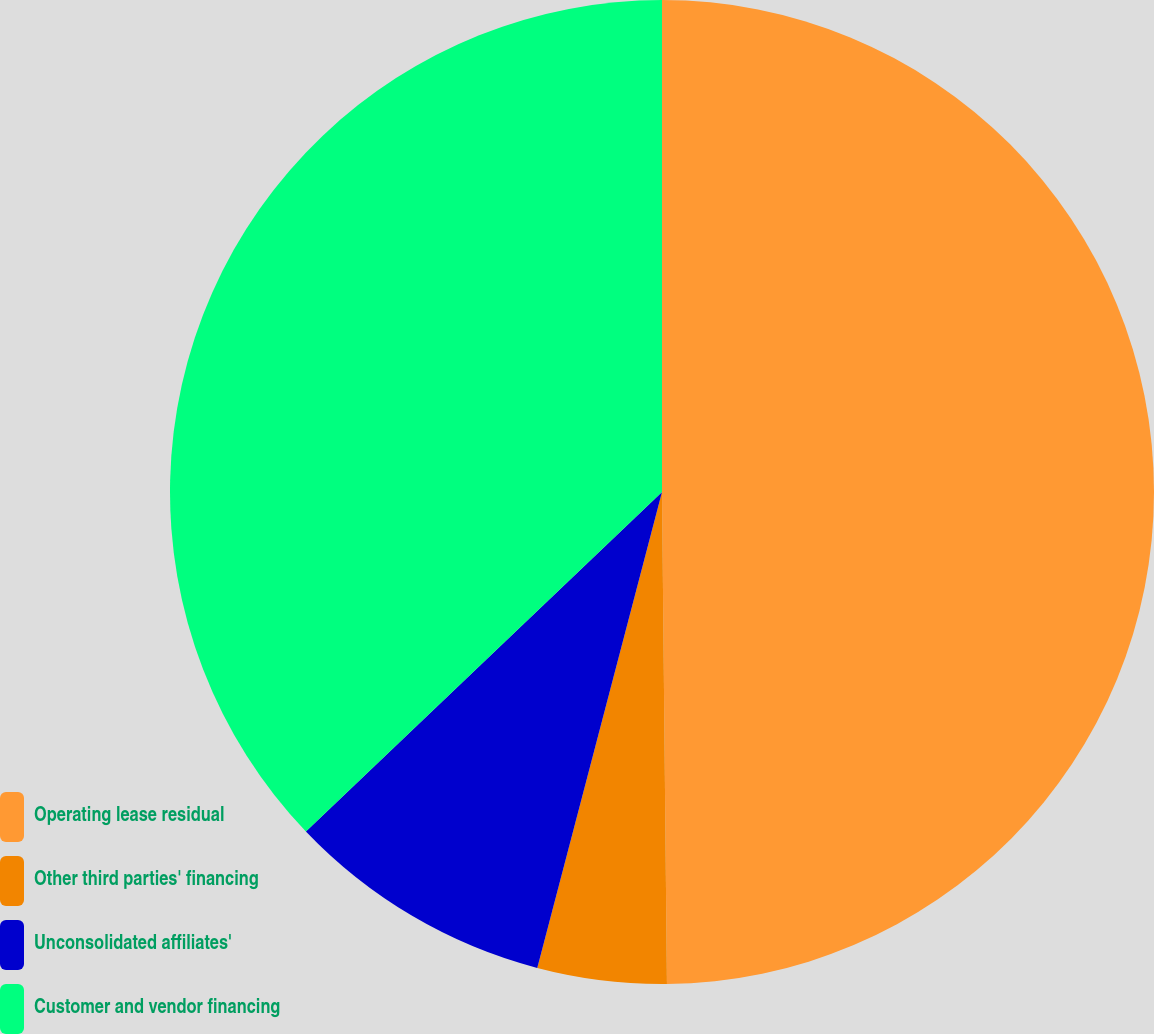Convert chart. <chart><loc_0><loc_0><loc_500><loc_500><pie_chart><fcel>Operating lease residual<fcel>Other third parties' financing<fcel>Unconsolidated affiliates'<fcel>Customer and vendor financing<nl><fcel>49.84%<fcel>4.24%<fcel>8.8%<fcel>37.12%<nl></chart> 